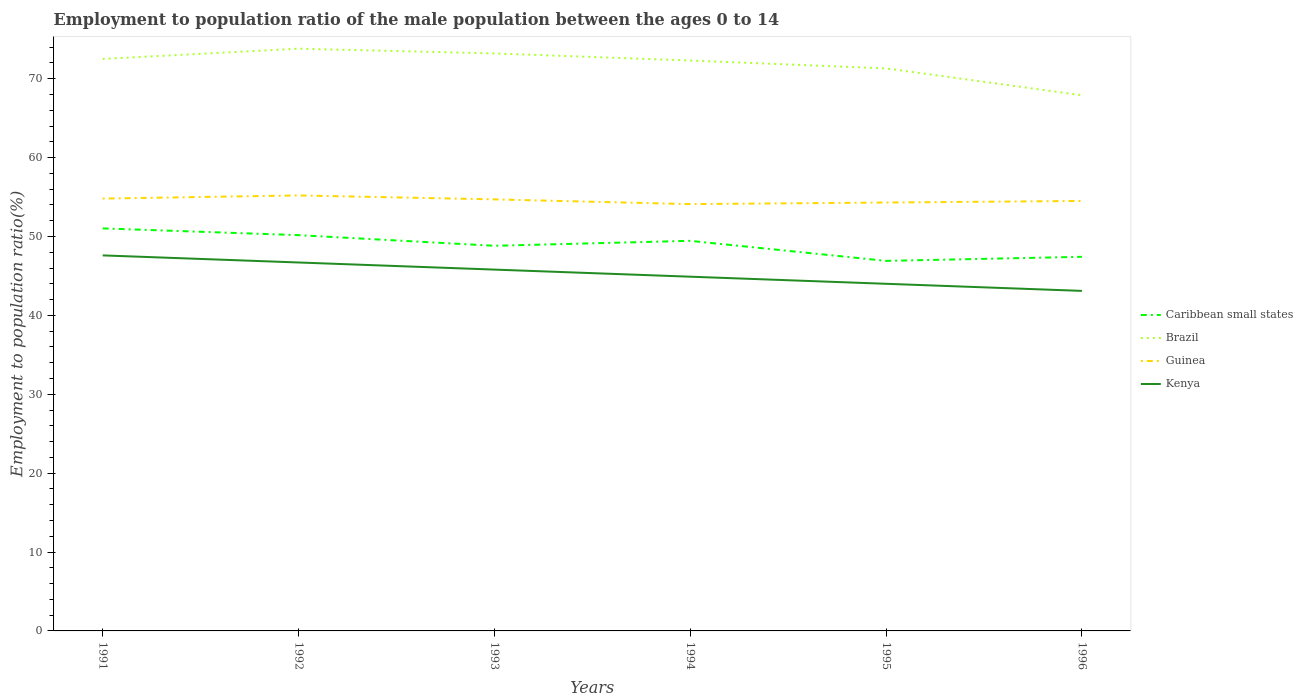Is the number of lines equal to the number of legend labels?
Your answer should be compact. Yes. Across all years, what is the maximum employment to population ratio in Kenya?
Your answer should be very brief. 43.1. What is the total employment to population ratio in Brazil in the graph?
Your answer should be compact. 5.9. What is the difference between the highest and the second highest employment to population ratio in Brazil?
Offer a very short reply. 5.9. What is the difference between the highest and the lowest employment to population ratio in Caribbean small states?
Make the answer very short. 3. Is the employment to population ratio in Guinea strictly greater than the employment to population ratio in Kenya over the years?
Offer a very short reply. No. How many years are there in the graph?
Provide a succinct answer. 6. What is the difference between two consecutive major ticks on the Y-axis?
Ensure brevity in your answer.  10. Are the values on the major ticks of Y-axis written in scientific E-notation?
Provide a short and direct response. No. Does the graph contain grids?
Offer a very short reply. No. Where does the legend appear in the graph?
Provide a short and direct response. Center right. How many legend labels are there?
Your answer should be very brief. 4. What is the title of the graph?
Provide a succinct answer. Employment to population ratio of the male population between the ages 0 to 14. What is the label or title of the X-axis?
Provide a succinct answer. Years. What is the label or title of the Y-axis?
Give a very brief answer. Employment to population ratio(%). What is the Employment to population ratio(%) in Caribbean small states in 1991?
Keep it short and to the point. 51.02. What is the Employment to population ratio(%) in Brazil in 1991?
Keep it short and to the point. 72.5. What is the Employment to population ratio(%) in Guinea in 1991?
Your answer should be very brief. 54.8. What is the Employment to population ratio(%) in Kenya in 1991?
Your answer should be very brief. 47.6. What is the Employment to population ratio(%) in Caribbean small states in 1992?
Offer a very short reply. 50.16. What is the Employment to population ratio(%) of Brazil in 1992?
Make the answer very short. 73.8. What is the Employment to population ratio(%) of Guinea in 1992?
Keep it short and to the point. 55.2. What is the Employment to population ratio(%) of Kenya in 1992?
Make the answer very short. 46.7. What is the Employment to population ratio(%) of Caribbean small states in 1993?
Your response must be concise. 48.82. What is the Employment to population ratio(%) in Brazil in 1993?
Ensure brevity in your answer.  73.2. What is the Employment to population ratio(%) of Guinea in 1993?
Your answer should be compact. 54.7. What is the Employment to population ratio(%) of Kenya in 1993?
Give a very brief answer. 45.8. What is the Employment to population ratio(%) in Caribbean small states in 1994?
Your answer should be compact. 49.44. What is the Employment to population ratio(%) in Brazil in 1994?
Your answer should be very brief. 72.3. What is the Employment to population ratio(%) in Guinea in 1994?
Your response must be concise. 54.1. What is the Employment to population ratio(%) in Kenya in 1994?
Provide a short and direct response. 44.9. What is the Employment to population ratio(%) in Caribbean small states in 1995?
Ensure brevity in your answer.  46.9. What is the Employment to population ratio(%) of Brazil in 1995?
Offer a very short reply. 71.3. What is the Employment to population ratio(%) of Guinea in 1995?
Offer a very short reply. 54.3. What is the Employment to population ratio(%) in Kenya in 1995?
Offer a very short reply. 44. What is the Employment to population ratio(%) in Caribbean small states in 1996?
Make the answer very short. 47.42. What is the Employment to population ratio(%) in Brazil in 1996?
Your response must be concise. 67.9. What is the Employment to population ratio(%) in Guinea in 1996?
Ensure brevity in your answer.  54.5. What is the Employment to population ratio(%) in Kenya in 1996?
Give a very brief answer. 43.1. Across all years, what is the maximum Employment to population ratio(%) of Caribbean small states?
Offer a terse response. 51.02. Across all years, what is the maximum Employment to population ratio(%) of Brazil?
Offer a very short reply. 73.8. Across all years, what is the maximum Employment to population ratio(%) of Guinea?
Your answer should be very brief. 55.2. Across all years, what is the maximum Employment to population ratio(%) of Kenya?
Give a very brief answer. 47.6. Across all years, what is the minimum Employment to population ratio(%) of Caribbean small states?
Your answer should be compact. 46.9. Across all years, what is the minimum Employment to population ratio(%) in Brazil?
Make the answer very short. 67.9. Across all years, what is the minimum Employment to population ratio(%) in Guinea?
Your answer should be compact. 54.1. Across all years, what is the minimum Employment to population ratio(%) of Kenya?
Your answer should be very brief. 43.1. What is the total Employment to population ratio(%) of Caribbean small states in the graph?
Offer a terse response. 293.77. What is the total Employment to population ratio(%) in Brazil in the graph?
Keep it short and to the point. 431. What is the total Employment to population ratio(%) of Guinea in the graph?
Provide a succinct answer. 327.6. What is the total Employment to population ratio(%) in Kenya in the graph?
Your answer should be compact. 272.1. What is the difference between the Employment to population ratio(%) in Caribbean small states in 1991 and that in 1992?
Give a very brief answer. 0.86. What is the difference between the Employment to population ratio(%) of Brazil in 1991 and that in 1992?
Give a very brief answer. -1.3. What is the difference between the Employment to population ratio(%) of Caribbean small states in 1991 and that in 1993?
Ensure brevity in your answer.  2.21. What is the difference between the Employment to population ratio(%) of Guinea in 1991 and that in 1993?
Your answer should be very brief. 0.1. What is the difference between the Employment to population ratio(%) of Caribbean small states in 1991 and that in 1994?
Ensure brevity in your answer.  1.58. What is the difference between the Employment to population ratio(%) in Brazil in 1991 and that in 1994?
Provide a short and direct response. 0.2. What is the difference between the Employment to population ratio(%) in Guinea in 1991 and that in 1994?
Ensure brevity in your answer.  0.7. What is the difference between the Employment to population ratio(%) of Kenya in 1991 and that in 1994?
Ensure brevity in your answer.  2.7. What is the difference between the Employment to population ratio(%) in Caribbean small states in 1991 and that in 1995?
Your response must be concise. 4.12. What is the difference between the Employment to population ratio(%) of Brazil in 1991 and that in 1995?
Your response must be concise. 1.2. What is the difference between the Employment to population ratio(%) of Caribbean small states in 1991 and that in 1996?
Your answer should be compact. 3.6. What is the difference between the Employment to population ratio(%) in Brazil in 1991 and that in 1996?
Offer a terse response. 4.6. What is the difference between the Employment to population ratio(%) in Guinea in 1991 and that in 1996?
Ensure brevity in your answer.  0.3. What is the difference between the Employment to population ratio(%) in Caribbean small states in 1992 and that in 1993?
Give a very brief answer. 1.35. What is the difference between the Employment to population ratio(%) of Brazil in 1992 and that in 1993?
Your answer should be very brief. 0.6. What is the difference between the Employment to population ratio(%) of Caribbean small states in 1992 and that in 1994?
Keep it short and to the point. 0.72. What is the difference between the Employment to population ratio(%) in Brazil in 1992 and that in 1994?
Ensure brevity in your answer.  1.5. What is the difference between the Employment to population ratio(%) in Kenya in 1992 and that in 1994?
Provide a short and direct response. 1.8. What is the difference between the Employment to population ratio(%) in Caribbean small states in 1992 and that in 1995?
Your answer should be compact. 3.26. What is the difference between the Employment to population ratio(%) in Brazil in 1992 and that in 1995?
Give a very brief answer. 2.5. What is the difference between the Employment to population ratio(%) in Guinea in 1992 and that in 1995?
Keep it short and to the point. 0.9. What is the difference between the Employment to population ratio(%) in Kenya in 1992 and that in 1995?
Keep it short and to the point. 2.7. What is the difference between the Employment to population ratio(%) in Caribbean small states in 1992 and that in 1996?
Your answer should be compact. 2.74. What is the difference between the Employment to population ratio(%) in Brazil in 1992 and that in 1996?
Your response must be concise. 5.9. What is the difference between the Employment to population ratio(%) in Caribbean small states in 1993 and that in 1994?
Your response must be concise. -0.63. What is the difference between the Employment to population ratio(%) of Guinea in 1993 and that in 1994?
Provide a succinct answer. 0.6. What is the difference between the Employment to population ratio(%) in Caribbean small states in 1993 and that in 1995?
Your answer should be compact. 1.91. What is the difference between the Employment to population ratio(%) of Kenya in 1993 and that in 1995?
Provide a succinct answer. 1.8. What is the difference between the Employment to population ratio(%) in Caribbean small states in 1993 and that in 1996?
Give a very brief answer. 1.4. What is the difference between the Employment to population ratio(%) of Brazil in 1993 and that in 1996?
Give a very brief answer. 5.3. What is the difference between the Employment to population ratio(%) in Guinea in 1993 and that in 1996?
Ensure brevity in your answer.  0.2. What is the difference between the Employment to population ratio(%) in Kenya in 1993 and that in 1996?
Your response must be concise. 2.7. What is the difference between the Employment to population ratio(%) in Caribbean small states in 1994 and that in 1995?
Ensure brevity in your answer.  2.54. What is the difference between the Employment to population ratio(%) of Brazil in 1994 and that in 1995?
Provide a short and direct response. 1. What is the difference between the Employment to population ratio(%) of Kenya in 1994 and that in 1995?
Offer a very short reply. 0.9. What is the difference between the Employment to population ratio(%) in Caribbean small states in 1994 and that in 1996?
Your response must be concise. 2.02. What is the difference between the Employment to population ratio(%) of Brazil in 1994 and that in 1996?
Make the answer very short. 4.4. What is the difference between the Employment to population ratio(%) of Caribbean small states in 1995 and that in 1996?
Provide a short and direct response. -0.52. What is the difference between the Employment to population ratio(%) of Kenya in 1995 and that in 1996?
Your response must be concise. 0.9. What is the difference between the Employment to population ratio(%) in Caribbean small states in 1991 and the Employment to population ratio(%) in Brazil in 1992?
Give a very brief answer. -22.78. What is the difference between the Employment to population ratio(%) of Caribbean small states in 1991 and the Employment to population ratio(%) of Guinea in 1992?
Your response must be concise. -4.18. What is the difference between the Employment to population ratio(%) in Caribbean small states in 1991 and the Employment to population ratio(%) in Kenya in 1992?
Provide a short and direct response. 4.32. What is the difference between the Employment to population ratio(%) of Brazil in 1991 and the Employment to population ratio(%) of Guinea in 1992?
Your answer should be compact. 17.3. What is the difference between the Employment to population ratio(%) of Brazil in 1991 and the Employment to population ratio(%) of Kenya in 1992?
Give a very brief answer. 25.8. What is the difference between the Employment to population ratio(%) of Caribbean small states in 1991 and the Employment to population ratio(%) of Brazil in 1993?
Make the answer very short. -22.18. What is the difference between the Employment to population ratio(%) of Caribbean small states in 1991 and the Employment to population ratio(%) of Guinea in 1993?
Your response must be concise. -3.68. What is the difference between the Employment to population ratio(%) in Caribbean small states in 1991 and the Employment to population ratio(%) in Kenya in 1993?
Give a very brief answer. 5.22. What is the difference between the Employment to population ratio(%) of Brazil in 1991 and the Employment to population ratio(%) of Kenya in 1993?
Provide a succinct answer. 26.7. What is the difference between the Employment to population ratio(%) in Guinea in 1991 and the Employment to population ratio(%) in Kenya in 1993?
Ensure brevity in your answer.  9. What is the difference between the Employment to population ratio(%) of Caribbean small states in 1991 and the Employment to population ratio(%) of Brazil in 1994?
Your response must be concise. -21.28. What is the difference between the Employment to population ratio(%) of Caribbean small states in 1991 and the Employment to population ratio(%) of Guinea in 1994?
Provide a succinct answer. -3.08. What is the difference between the Employment to population ratio(%) of Caribbean small states in 1991 and the Employment to population ratio(%) of Kenya in 1994?
Your answer should be compact. 6.12. What is the difference between the Employment to population ratio(%) in Brazil in 1991 and the Employment to population ratio(%) in Kenya in 1994?
Offer a very short reply. 27.6. What is the difference between the Employment to population ratio(%) in Caribbean small states in 1991 and the Employment to population ratio(%) in Brazil in 1995?
Offer a very short reply. -20.28. What is the difference between the Employment to population ratio(%) of Caribbean small states in 1991 and the Employment to population ratio(%) of Guinea in 1995?
Your answer should be compact. -3.28. What is the difference between the Employment to population ratio(%) of Caribbean small states in 1991 and the Employment to population ratio(%) of Kenya in 1995?
Keep it short and to the point. 7.02. What is the difference between the Employment to population ratio(%) of Brazil in 1991 and the Employment to population ratio(%) of Guinea in 1995?
Give a very brief answer. 18.2. What is the difference between the Employment to population ratio(%) of Brazil in 1991 and the Employment to population ratio(%) of Kenya in 1995?
Offer a very short reply. 28.5. What is the difference between the Employment to population ratio(%) in Guinea in 1991 and the Employment to population ratio(%) in Kenya in 1995?
Make the answer very short. 10.8. What is the difference between the Employment to population ratio(%) of Caribbean small states in 1991 and the Employment to population ratio(%) of Brazil in 1996?
Provide a short and direct response. -16.88. What is the difference between the Employment to population ratio(%) of Caribbean small states in 1991 and the Employment to population ratio(%) of Guinea in 1996?
Make the answer very short. -3.48. What is the difference between the Employment to population ratio(%) of Caribbean small states in 1991 and the Employment to population ratio(%) of Kenya in 1996?
Provide a succinct answer. 7.92. What is the difference between the Employment to population ratio(%) of Brazil in 1991 and the Employment to population ratio(%) of Guinea in 1996?
Your answer should be very brief. 18. What is the difference between the Employment to population ratio(%) of Brazil in 1991 and the Employment to population ratio(%) of Kenya in 1996?
Offer a terse response. 29.4. What is the difference between the Employment to population ratio(%) of Guinea in 1991 and the Employment to population ratio(%) of Kenya in 1996?
Provide a short and direct response. 11.7. What is the difference between the Employment to population ratio(%) in Caribbean small states in 1992 and the Employment to population ratio(%) in Brazil in 1993?
Ensure brevity in your answer.  -23.04. What is the difference between the Employment to population ratio(%) in Caribbean small states in 1992 and the Employment to population ratio(%) in Guinea in 1993?
Provide a short and direct response. -4.54. What is the difference between the Employment to population ratio(%) in Caribbean small states in 1992 and the Employment to population ratio(%) in Kenya in 1993?
Make the answer very short. 4.36. What is the difference between the Employment to population ratio(%) of Brazil in 1992 and the Employment to population ratio(%) of Guinea in 1993?
Make the answer very short. 19.1. What is the difference between the Employment to population ratio(%) in Caribbean small states in 1992 and the Employment to population ratio(%) in Brazil in 1994?
Provide a short and direct response. -22.14. What is the difference between the Employment to population ratio(%) in Caribbean small states in 1992 and the Employment to population ratio(%) in Guinea in 1994?
Offer a terse response. -3.94. What is the difference between the Employment to population ratio(%) in Caribbean small states in 1992 and the Employment to population ratio(%) in Kenya in 1994?
Provide a short and direct response. 5.26. What is the difference between the Employment to population ratio(%) in Brazil in 1992 and the Employment to population ratio(%) in Guinea in 1994?
Your response must be concise. 19.7. What is the difference between the Employment to population ratio(%) of Brazil in 1992 and the Employment to population ratio(%) of Kenya in 1994?
Give a very brief answer. 28.9. What is the difference between the Employment to population ratio(%) of Guinea in 1992 and the Employment to population ratio(%) of Kenya in 1994?
Offer a very short reply. 10.3. What is the difference between the Employment to population ratio(%) of Caribbean small states in 1992 and the Employment to population ratio(%) of Brazil in 1995?
Keep it short and to the point. -21.14. What is the difference between the Employment to population ratio(%) of Caribbean small states in 1992 and the Employment to population ratio(%) of Guinea in 1995?
Your response must be concise. -4.14. What is the difference between the Employment to population ratio(%) in Caribbean small states in 1992 and the Employment to population ratio(%) in Kenya in 1995?
Ensure brevity in your answer.  6.16. What is the difference between the Employment to population ratio(%) in Brazil in 1992 and the Employment to population ratio(%) in Guinea in 1995?
Provide a short and direct response. 19.5. What is the difference between the Employment to population ratio(%) of Brazil in 1992 and the Employment to population ratio(%) of Kenya in 1995?
Your answer should be compact. 29.8. What is the difference between the Employment to population ratio(%) of Caribbean small states in 1992 and the Employment to population ratio(%) of Brazil in 1996?
Offer a very short reply. -17.74. What is the difference between the Employment to population ratio(%) of Caribbean small states in 1992 and the Employment to population ratio(%) of Guinea in 1996?
Keep it short and to the point. -4.34. What is the difference between the Employment to population ratio(%) of Caribbean small states in 1992 and the Employment to population ratio(%) of Kenya in 1996?
Your response must be concise. 7.06. What is the difference between the Employment to population ratio(%) of Brazil in 1992 and the Employment to population ratio(%) of Guinea in 1996?
Your response must be concise. 19.3. What is the difference between the Employment to population ratio(%) in Brazil in 1992 and the Employment to population ratio(%) in Kenya in 1996?
Your answer should be compact. 30.7. What is the difference between the Employment to population ratio(%) of Guinea in 1992 and the Employment to population ratio(%) of Kenya in 1996?
Provide a short and direct response. 12.1. What is the difference between the Employment to population ratio(%) of Caribbean small states in 1993 and the Employment to population ratio(%) of Brazil in 1994?
Your answer should be very brief. -23.48. What is the difference between the Employment to population ratio(%) in Caribbean small states in 1993 and the Employment to population ratio(%) in Guinea in 1994?
Provide a succinct answer. -5.28. What is the difference between the Employment to population ratio(%) of Caribbean small states in 1993 and the Employment to population ratio(%) of Kenya in 1994?
Your answer should be very brief. 3.92. What is the difference between the Employment to population ratio(%) in Brazil in 1993 and the Employment to population ratio(%) in Kenya in 1994?
Provide a short and direct response. 28.3. What is the difference between the Employment to population ratio(%) in Caribbean small states in 1993 and the Employment to population ratio(%) in Brazil in 1995?
Offer a very short reply. -22.48. What is the difference between the Employment to population ratio(%) in Caribbean small states in 1993 and the Employment to population ratio(%) in Guinea in 1995?
Provide a succinct answer. -5.48. What is the difference between the Employment to population ratio(%) of Caribbean small states in 1993 and the Employment to population ratio(%) of Kenya in 1995?
Provide a short and direct response. 4.82. What is the difference between the Employment to population ratio(%) of Brazil in 1993 and the Employment to population ratio(%) of Kenya in 1995?
Your answer should be very brief. 29.2. What is the difference between the Employment to population ratio(%) in Guinea in 1993 and the Employment to population ratio(%) in Kenya in 1995?
Your answer should be compact. 10.7. What is the difference between the Employment to population ratio(%) in Caribbean small states in 1993 and the Employment to population ratio(%) in Brazil in 1996?
Your answer should be very brief. -19.08. What is the difference between the Employment to population ratio(%) in Caribbean small states in 1993 and the Employment to population ratio(%) in Guinea in 1996?
Your answer should be compact. -5.68. What is the difference between the Employment to population ratio(%) of Caribbean small states in 1993 and the Employment to population ratio(%) of Kenya in 1996?
Give a very brief answer. 5.72. What is the difference between the Employment to population ratio(%) of Brazil in 1993 and the Employment to population ratio(%) of Guinea in 1996?
Offer a very short reply. 18.7. What is the difference between the Employment to population ratio(%) of Brazil in 1993 and the Employment to population ratio(%) of Kenya in 1996?
Offer a very short reply. 30.1. What is the difference between the Employment to population ratio(%) of Caribbean small states in 1994 and the Employment to population ratio(%) of Brazil in 1995?
Offer a very short reply. -21.86. What is the difference between the Employment to population ratio(%) in Caribbean small states in 1994 and the Employment to population ratio(%) in Guinea in 1995?
Your answer should be compact. -4.86. What is the difference between the Employment to population ratio(%) in Caribbean small states in 1994 and the Employment to population ratio(%) in Kenya in 1995?
Your response must be concise. 5.44. What is the difference between the Employment to population ratio(%) of Brazil in 1994 and the Employment to population ratio(%) of Guinea in 1995?
Your answer should be compact. 18. What is the difference between the Employment to population ratio(%) of Brazil in 1994 and the Employment to population ratio(%) of Kenya in 1995?
Your response must be concise. 28.3. What is the difference between the Employment to population ratio(%) of Guinea in 1994 and the Employment to population ratio(%) of Kenya in 1995?
Your answer should be compact. 10.1. What is the difference between the Employment to population ratio(%) of Caribbean small states in 1994 and the Employment to population ratio(%) of Brazil in 1996?
Provide a succinct answer. -18.46. What is the difference between the Employment to population ratio(%) of Caribbean small states in 1994 and the Employment to population ratio(%) of Guinea in 1996?
Ensure brevity in your answer.  -5.06. What is the difference between the Employment to population ratio(%) in Caribbean small states in 1994 and the Employment to population ratio(%) in Kenya in 1996?
Provide a succinct answer. 6.34. What is the difference between the Employment to population ratio(%) in Brazil in 1994 and the Employment to population ratio(%) in Kenya in 1996?
Offer a terse response. 29.2. What is the difference between the Employment to population ratio(%) in Guinea in 1994 and the Employment to population ratio(%) in Kenya in 1996?
Ensure brevity in your answer.  11. What is the difference between the Employment to population ratio(%) in Caribbean small states in 1995 and the Employment to population ratio(%) in Brazil in 1996?
Keep it short and to the point. -21. What is the difference between the Employment to population ratio(%) of Caribbean small states in 1995 and the Employment to population ratio(%) of Guinea in 1996?
Keep it short and to the point. -7.6. What is the difference between the Employment to population ratio(%) of Caribbean small states in 1995 and the Employment to population ratio(%) of Kenya in 1996?
Provide a succinct answer. 3.8. What is the difference between the Employment to population ratio(%) in Brazil in 1995 and the Employment to population ratio(%) in Guinea in 1996?
Your answer should be compact. 16.8. What is the difference between the Employment to population ratio(%) of Brazil in 1995 and the Employment to population ratio(%) of Kenya in 1996?
Your answer should be very brief. 28.2. What is the average Employment to population ratio(%) in Caribbean small states per year?
Provide a succinct answer. 48.96. What is the average Employment to population ratio(%) of Brazil per year?
Offer a terse response. 71.83. What is the average Employment to population ratio(%) of Guinea per year?
Ensure brevity in your answer.  54.6. What is the average Employment to population ratio(%) of Kenya per year?
Keep it short and to the point. 45.35. In the year 1991, what is the difference between the Employment to population ratio(%) of Caribbean small states and Employment to population ratio(%) of Brazil?
Offer a terse response. -21.48. In the year 1991, what is the difference between the Employment to population ratio(%) of Caribbean small states and Employment to population ratio(%) of Guinea?
Ensure brevity in your answer.  -3.78. In the year 1991, what is the difference between the Employment to population ratio(%) of Caribbean small states and Employment to population ratio(%) of Kenya?
Your answer should be very brief. 3.42. In the year 1991, what is the difference between the Employment to population ratio(%) in Brazil and Employment to population ratio(%) in Guinea?
Keep it short and to the point. 17.7. In the year 1991, what is the difference between the Employment to population ratio(%) in Brazil and Employment to population ratio(%) in Kenya?
Your response must be concise. 24.9. In the year 1992, what is the difference between the Employment to population ratio(%) in Caribbean small states and Employment to population ratio(%) in Brazil?
Your answer should be very brief. -23.64. In the year 1992, what is the difference between the Employment to population ratio(%) in Caribbean small states and Employment to population ratio(%) in Guinea?
Make the answer very short. -5.04. In the year 1992, what is the difference between the Employment to population ratio(%) in Caribbean small states and Employment to population ratio(%) in Kenya?
Give a very brief answer. 3.46. In the year 1992, what is the difference between the Employment to population ratio(%) in Brazil and Employment to population ratio(%) in Guinea?
Your response must be concise. 18.6. In the year 1992, what is the difference between the Employment to population ratio(%) of Brazil and Employment to population ratio(%) of Kenya?
Make the answer very short. 27.1. In the year 1993, what is the difference between the Employment to population ratio(%) of Caribbean small states and Employment to population ratio(%) of Brazil?
Provide a short and direct response. -24.38. In the year 1993, what is the difference between the Employment to population ratio(%) of Caribbean small states and Employment to population ratio(%) of Guinea?
Offer a terse response. -5.88. In the year 1993, what is the difference between the Employment to population ratio(%) in Caribbean small states and Employment to population ratio(%) in Kenya?
Offer a very short reply. 3.02. In the year 1993, what is the difference between the Employment to population ratio(%) in Brazil and Employment to population ratio(%) in Kenya?
Provide a short and direct response. 27.4. In the year 1993, what is the difference between the Employment to population ratio(%) in Guinea and Employment to population ratio(%) in Kenya?
Your answer should be compact. 8.9. In the year 1994, what is the difference between the Employment to population ratio(%) of Caribbean small states and Employment to population ratio(%) of Brazil?
Keep it short and to the point. -22.86. In the year 1994, what is the difference between the Employment to population ratio(%) of Caribbean small states and Employment to population ratio(%) of Guinea?
Make the answer very short. -4.66. In the year 1994, what is the difference between the Employment to population ratio(%) in Caribbean small states and Employment to population ratio(%) in Kenya?
Your answer should be compact. 4.54. In the year 1994, what is the difference between the Employment to population ratio(%) of Brazil and Employment to population ratio(%) of Guinea?
Give a very brief answer. 18.2. In the year 1994, what is the difference between the Employment to population ratio(%) of Brazil and Employment to population ratio(%) of Kenya?
Keep it short and to the point. 27.4. In the year 1995, what is the difference between the Employment to population ratio(%) of Caribbean small states and Employment to population ratio(%) of Brazil?
Your response must be concise. -24.4. In the year 1995, what is the difference between the Employment to population ratio(%) of Caribbean small states and Employment to population ratio(%) of Guinea?
Ensure brevity in your answer.  -7.4. In the year 1995, what is the difference between the Employment to population ratio(%) in Caribbean small states and Employment to population ratio(%) in Kenya?
Provide a succinct answer. 2.9. In the year 1995, what is the difference between the Employment to population ratio(%) in Brazil and Employment to population ratio(%) in Kenya?
Your answer should be compact. 27.3. In the year 1995, what is the difference between the Employment to population ratio(%) of Guinea and Employment to population ratio(%) of Kenya?
Offer a very short reply. 10.3. In the year 1996, what is the difference between the Employment to population ratio(%) in Caribbean small states and Employment to population ratio(%) in Brazil?
Your answer should be very brief. -20.48. In the year 1996, what is the difference between the Employment to population ratio(%) of Caribbean small states and Employment to population ratio(%) of Guinea?
Give a very brief answer. -7.08. In the year 1996, what is the difference between the Employment to population ratio(%) of Caribbean small states and Employment to population ratio(%) of Kenya?
Provide a succinct answer. 4.32. In the year 1996, what is the difference between the Employment to population ratio(%) of Brazil and Employment to population ratio(%) of Kenya?
Provide a short and direct response. 24.8. In the year 1996, what is the difference between the Employment to population ratio(%) of Guinea and Employment to population ratio(%) of Kenya?
Give a very brief answer. 11.4. What is the ratio of the Employment to population ratio(%) in Caribbean small states in 1991 to that in 1992?
Ensure brevity in your answer.  1.02. What is the ratio of the Employment to population ratio(%) in Brazil in 1991 to that in 1992?
Provide a short and direct response. 0.98. What is the ratio of the Employment to population ratio(%) of Kenya in 1991 to that in 1992?
Your answer should be very brief. 1.02. What is the ratio of the Employment to population ratio(%) in Caribbean small states in 1991 to that in 1993?
Offer a terse response. 1.05. What is the ratio of the Employment to population ratio(%) in Brazil in 1991 to that in 1993?
Offer a terse response. 0.99. What is the ratio of the Employment to population ratio(%) of Kenya in 1991 to that in 1993?
Your response must be concise. 1.04. What is the ratio of the Employment to population ratio(%) in Caribbean small states in 1991 to that in 1994?
Make the answer very short. 1.03. What is the ratio of the Employment to population ratio(%) of Brazil in 1991 to that in 1994?
Offer a very short reply. 1. What is the ratio of the Employment to population ratio(%) of Guinea in 1991 to that in 1994?
Offer a very short reply. 1.01. What is the ratio of the Employment to population ratio(%) of Kenya in 1991 to that in 1994?
Provide a short and direct response. 1.06. What is the ratio of the Employment to population ratio(%) of Caribbean small states in 1991 to that in 1995?
Offer a terse response. 1.09. What is the ratio of the Employment to population ratio(%) of Brazil in 1991 to that in 1995?
Offer a terse response. 1.02. What is the ratio of the Employment to population ratio(%) in Guinea in 1991 to that in 1995?
Give a very brief answer. 1.01. What is the ratio of the Employment to population ratio(%) in Kenya in 1991 to that in 1995?
Provide a succinct answer. 1.08. What is the ratio of the Employment to population ratio(%) of Caribbean small states in 1991 to that in 1996?
Ensure brevity in your answer.  1.08. What is the ratio of the Employment to population ratio(%) in Brazil in 1991 to that in 1996?
Ensure brevity in your answer.  1.07. What is the ratio of the Employment to population ratio(%) of Kenya in 1991 to that in 1996?
Keep it short and to the point. 1.1. What is the ratio of the Employment to population ratio(%) of Caribbean small states in 1992 to that in 1993?
Your answer should be compact. 1.03. What is the ratio of the Employment to population ratio(%) of Brazil in 1992 to that in 1993?
Ensure brevity in your answer.  1.01. What is the ratio of the Employment to population ratio(%) of Guinea in 1992 to that in 1993?
Your answer should be compact. 1.01. What is the ratio of the Employment to population ratio(%) of Kenya in 1992 to that in 1993?
Keep it short and to the point. 1.02. What is the ratio of the Employment to population ratio(%) of Caribbean small states in 1992 to that in 1994?
Offer a very short reply. 1.01. What is the ratio of the Employment to population ratio(%) of Brazil in 1992 to that in 1994?
Your answer should be compact. 1.02. What is the ratio of the Employment to population ratio(%) of Guinea in 1992 to that in 1994?
Offer a terse response. 1.02. What is the ratio of the Employment to population ratio(%) of Kenya in 1992 to that in 1994?
Provide a succinct answer. 1.04. What is the ratio of the Employment to population ratio(%) of Caribbean small states in 1992 to that in 1995?
Provide a succinct answer. 1.07. What is the ratio of the Employment to population ratio(%) of Brazil in 1992 to that in 1995?
Ensure brevity in your answer.  1.04. What is the ratio of the Employment to population ratio(%) of Guinea in 1992 to that in 1995?
Your answer should be very brief. 1.02. What is the ratio of the Employment to population ratio(%) of Kenya in 1992 to that in 1995?
Your response must be concise. 1.06. What is the ratio of the Employment to population ratio(%) in Caribbean small states in 1992 to that in 1996?
Your answer should be very brief. 1.06. What is the ratio of the Employment to population ratio(%) in Brazil in 1992 to that in 1996?
Offer a very short reply. 1.09. What is the ratio of the Employment to population ratio(%) in Guinea in 1992 to that in 1996?
Provide a succinct answer. 1.01. What is the ratio of the Employment to population ratio(%) in Kenya in 1992 to that in 1996?
Your answer should be very brief. 1.08. What is the ratio of the Employment to population ratio(%) of Caribbean small states in 1993 to that in 1994?
Make the answer very short. 0.99. What is the ratio of the Employment to population ratio(%) of Brazil in 1993 to that in 1994?
Keep it short and to the point. 1.01. What is the ratio of the Employment to population ratio(%) in Guinea in 1993 to that in 1994?
Keep it short and to the point. 1.01. What is the ratio of the Employment to population ratio(%) of Kenya in 1993 to that in 1994?
Your answer should be very brief. 1.02. What is the ratio of the Employment to population ratio(%) of Caribbean small states in 1993 to that in 1995?
Your answer should be compact. 1.04. What is the ratio of the Employment to population ratio(%) of Brazil in 1993 to that in 1995?
Your answer should be very brief. 1.03. What is the ratio of the Employment to population ratio(%) of Guinea in 1993 to that in 1995?
Offer a very short reply. 1.01. What is the ratio of the Employment to population ratio(%) of Kenya in 1993 to that in 1995?
Your answer should be very brief. 1.04. What is the ratio of the Employment to population ratio(%) in Caribbean small states in 1993 to that in 1996?
Your response must be concise. 1.03. What is the ratio of the Employment to population ratio(%) of Brazil in 1993 to that in 1996?
Your answer should be compact. 1.08. What is the ratio of the Employment to population ratio(%) in Kenya in 1993 to that in 1996?
Make the answer very short. 1.06. What is the ratio of the Employment to population ratio(%) in Caribbean small states in 1994 to that in 1995?
Provide a short and direct response. 1.05. What is the ratio of the Employment to population ratio(%) of Kenya in 1994 to that in 1995?
Your response must be concise. 1.02. What is the ratio of the Employment to population ratio(%) in Caribbean small states in 1994 to that in 1996?
Give a very brief answer. 1.04. What is the ratio of the Employment to population ratio(%) of Brazil in 1994 to that in 1996?
Offer a very short reply. 1.06. What is the ratio of the Employment to population ratio(%) of Kenya in 1994 to that in 1996?
Keep it short and to the point. 1.04. What is the ratio of the Employment to population ratio(%) of Caribbean small states in 1995 to that in 1996?
Ensure brevity in your answer.  0.99. What is the ratio of the Employment to population ratio(%) in Brazil in 1995 to that in 1996?
Make the answer very short. 1.05. What is the ratio of the Employment to population ratio(%) of Guinea in 1995 to that in 1996?
Your answer should be very brief. 1. What is the ratio of the Employment to population ratio(%) of Kenya in 1995 to that in 1996?
Ensure brevity in your answer.  1.02. What is the difference between the highest and the second highest Employment to population ratio(%) of Caribbean small states?
Provide a short and direct response. 0.86. What is the difference between the highest and the second highest Employment to population ratio(%) in Guinea?
Keep it short and to the point. 0.4. What is the difference between the highest and the second highest Employment to population ratio(%) in Kenya?
Provide a short and direct response. 0.9. What is the difference between the highest and the lowest Employment to population ratio(%) in Caribbean small states?
Provide a short and direct response. 4.12. What is the difference between the highest and the lowest Employment to population ratio(%) in Brazil?
Offer a terse response. 5.9. 